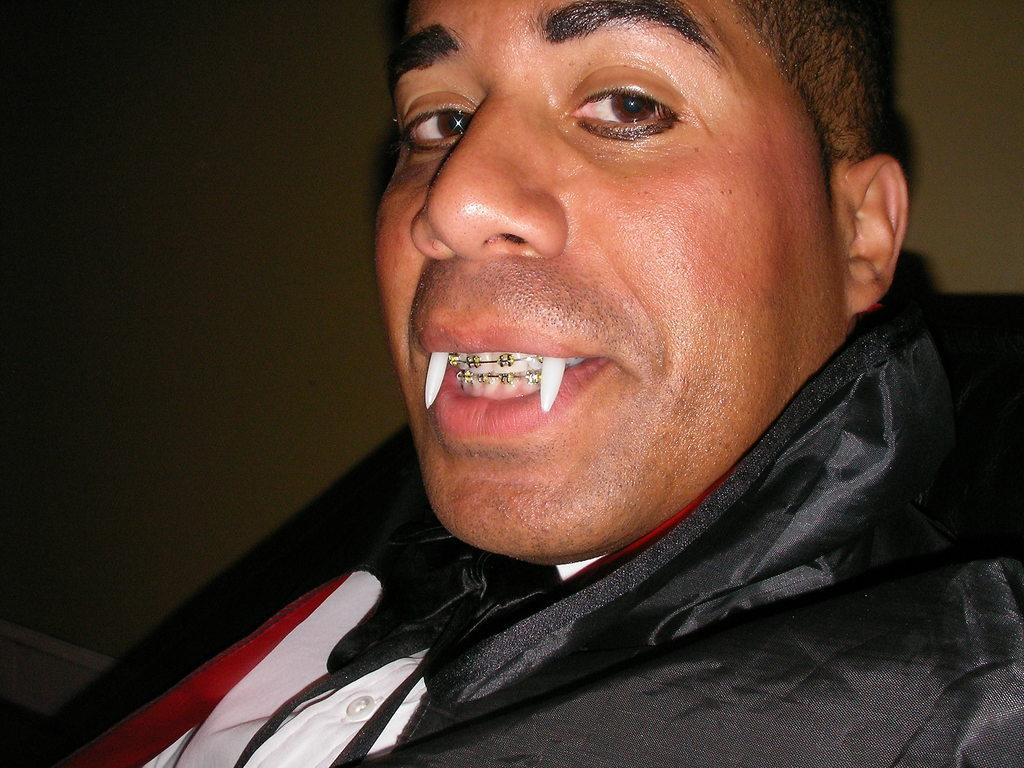Where was the image taken? The image was taken indoors. What can be seen in the background of the image? There is a wall in the background of the image. Can you describe the man on the right side of the image? The man has dental braces on his teeth and two devil teeth. What type of hobbies does the man have, as depicted in the image? The image does not provide any information about the man's hobbies. Can you describe the art or quilt featured in the image? There is no art or quilt present in the image. 